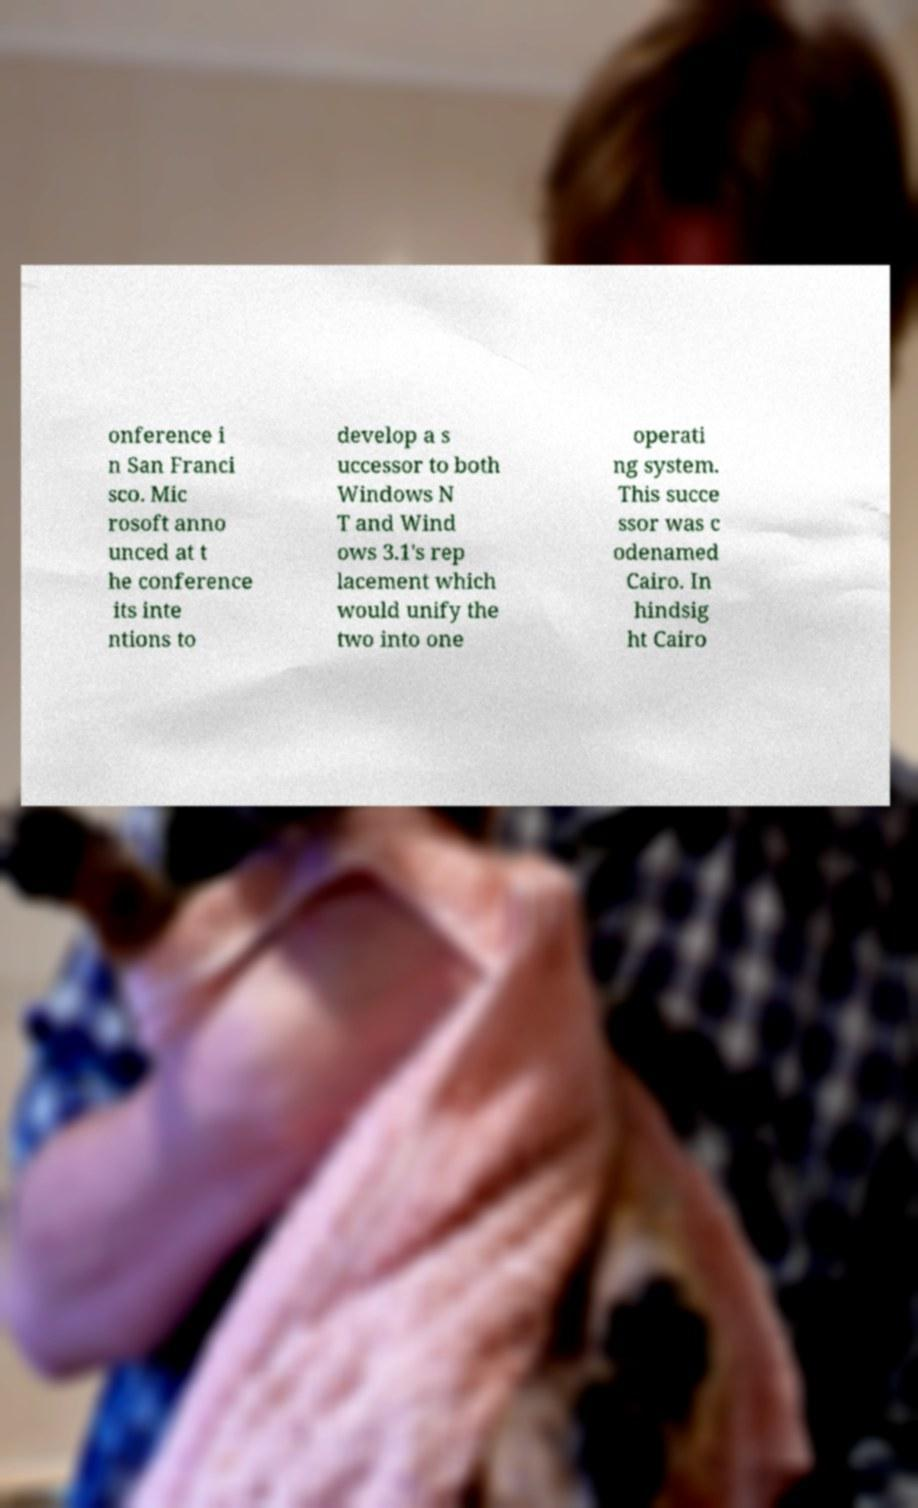Can you read and provide the text displayed in the image?This photo seems to have some interesting text. Can you extract and type it out for me? onference i n San Franci sco. Mic rosoft anno unced at t he conference its inte ntions to develop a s uccessor to both Windows N T and Wind ows 3.1's rep lacement which would unify the two into one operati ng system. This succe ssor was c odenamed Cairo. In hindsig ht Cairo 